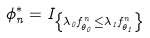<formula> <loc_0><loc_0><loc_500><loc_500>\phi _ { n } ^ { * } = I _ { \left \{ \lambda _ { 0 } f _ { \theta _ { 0 } } ^ { n } \leq \lambda _ { 1 } f _ { \theta _ { 1 } } ^ { n } \right \} }</formula> 